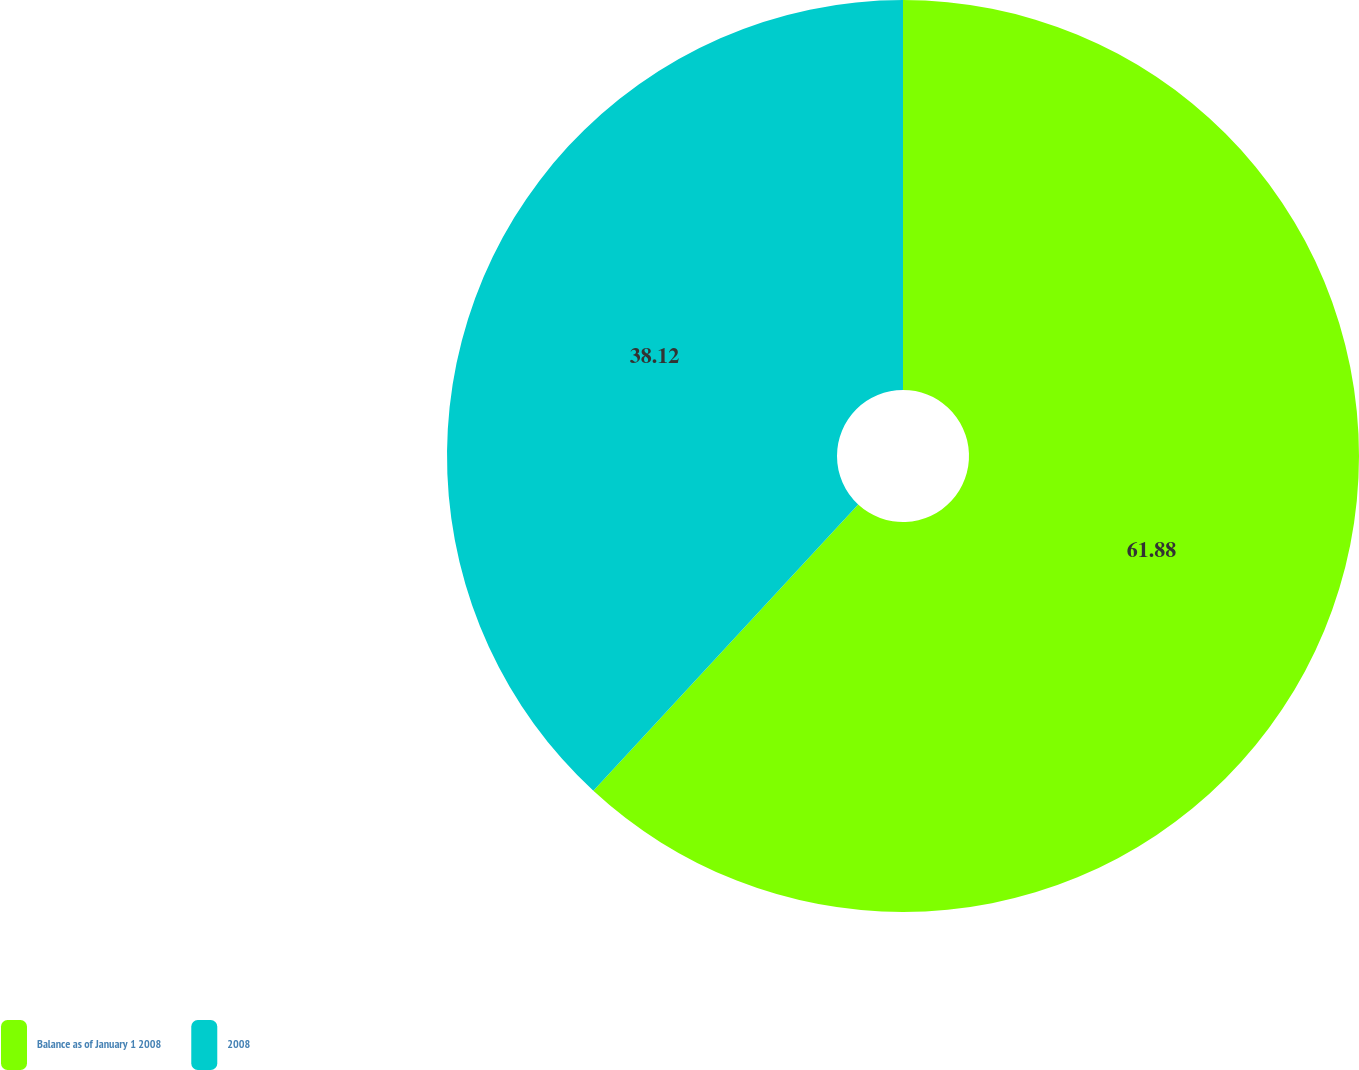Convert chart to OTSL. <chart><loc_0><loc_0><loc_500><loc_500><pie_chart><fcel>Balance as of January 1 2008<fcel>2008<nl><fcel>61.88%<fcel>38.12%<nl></chart> 